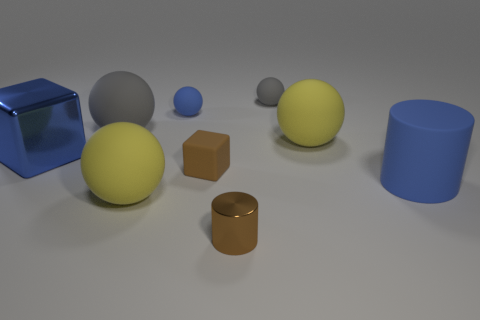Subtract all blue spheres. How many spheres are left? 4 Subtract 2 balls. How many balls are left? 3 Subtract all blue spheres. How many spheres are left? 4 Subtract all green balls. Subtract all brown blocks. How many balls are left? 5 Add 1 yellow spheres. How many objects exist? 10 Subtract all balls. How many objects are left? 4 Add 1 blue rubber things. How many blue rubber things exist? 3 Subtract 0 red cylinders. How many objects are left? 9 Subtract all cyan balls. Subtract all rubber cylinders. How many objects are left? 8 Add 1 tiny metallic cylinders. How many tiny metallic cylinders are left? 2 